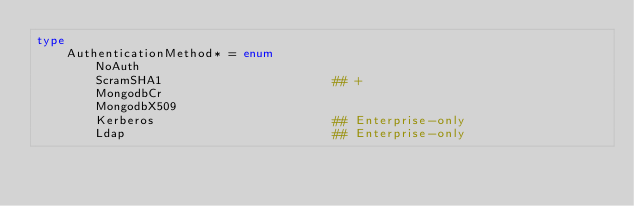Convert code to text. <code><loc_0><loc_0><loc_500><loc_500><_Nim_>type
    AuthenticationMethod* = enum
        NoAuth
        ScramSHA1                       ## +
        MongodbCr
        MongodbX509
        Kerberos                        ## Enterprise-only
        Ldap                            ## Enterprise-only
</code> 